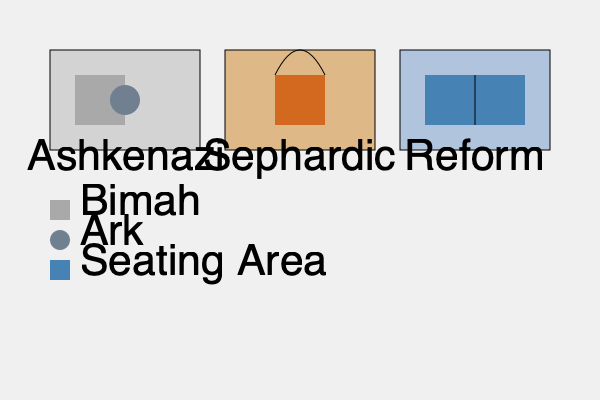Based on the diagram, which type of synagogue architecture typically features a centrally located bimah (raised platform) and ark? To answer this question, let's analyze the three synagogue layouts presented in the diagram:

1. Ashkenazi Synagogue:
   - The bimah (represented by the smaller square) is located in the center of the space.
   - The ark (represented by the circle) is positioned directly behind the bimah.

2. Sephardic Synagogue:
   - The bimah is located towards the front of the space.
   - There is no clear representation of an ark in this layout.

3. Reform Synagogue:
   - The seating area (larger rectangle) takes up most of the space.
   - There is a line dividing the front of the synagogue, possibly representing a raised area for the bimah and ark, but they are not centrally located.

The Ashkenazi synagogue layout is the only one that shows both the bimah and ark centrally located within the space. This arrangement is typical of traditional Ashkenazi synagogue architecture, where the Torah reading and prayer leading are conducted from the center of the congregation.
Answer: Ashkenazi 